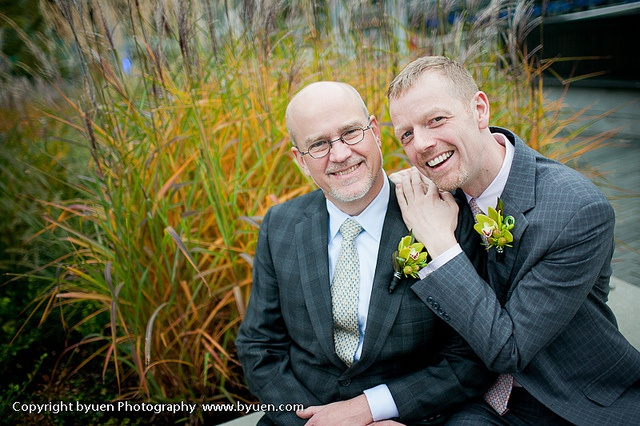Describe the objects in this image and their specific colors. I can see people in black, lightgray, blue, and gray tones, people in black, lightgray, blue, and pink tones, car in black, navy, and gray tones, tie in black, lightgray, lightblue, darkgray, and tan tones, and tie in black, gray, darkgray, and darkgreen tones in this image. 